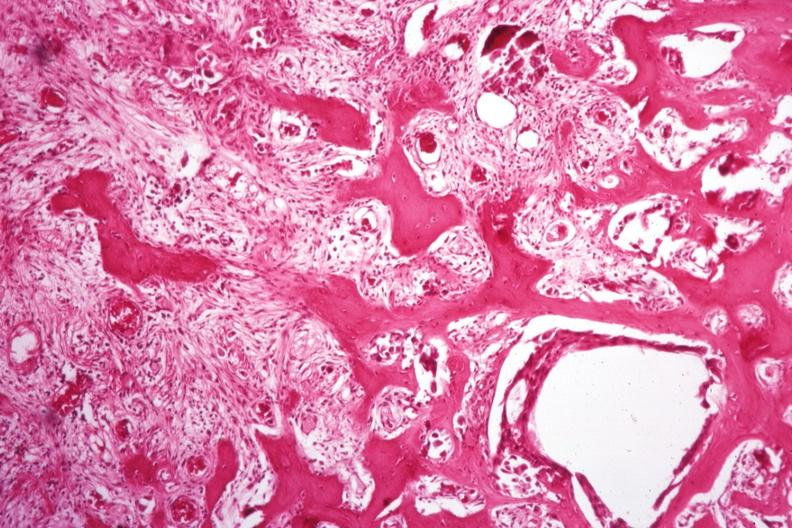does postpartum uterus show nice new bone formation tumor difficult to see?
Answer the question using a single word or phrase. No 